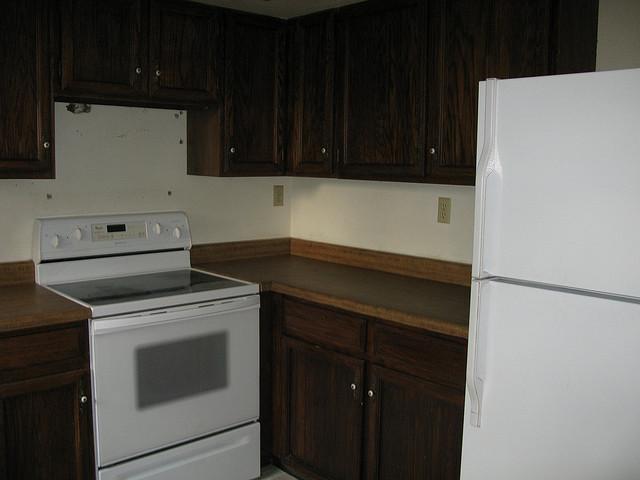What color is the shelf?
Concise answer only. Brown. How many candles are in this scene?
Quick response, please. 0. What is hanging on the freezer door?
Give a very brief answer. Nothing. Does the stove run on electric or gas?
Write a very short answer. Electric. Is there a dishwasher in this photo?
Concise answer only. No. Is there anything on the wall under the cabinet?
Write a very short answer. Yes. Is it a gas or electric stove?
Short answer required. Electric. Are the appliances stainless?
Quick response, please. No. Is there anything on the counter?
Give a very brief answer. No. What is the main color in the room?
Quick response, please. Brown. Is there a microwave in this photo?
Answer briefly. No. How is the stovetop powered?
Quick response, please. Electricity. What color is the stove?
Keep it brief. White. What style kitchen is it?
Keep it brief. Modern. How many appliances in this photo?
Short answer required. 2. How many rings are on the stove?
Keep it brief. 4. Does this place look lived in?
Give a very brief answer. No. What color are the cabinets?
Be succinct. Brown. Is the stove gas or electric?
Short answer required. Electric. What room is this?
Quick response, please. Kitchen. What color are the appliances?
Give a very brief answer. White. Where is the phone?
Concise answer only. Nowhere. Is this a modern microwave?
Write a very short answer. No. Are the lights on?
Write a very short answer. No. What is one advantage of the oven placement?
Give a very brief answer. Counter space. Is that a hood vent over the cooktop?
Quick response, please. No. What is on the refrigerator?
Short answer required. Nothing. What type of energy source does the stove use?
Be succinct. Electric. How many different types of door are visible?
Be succinct. 4. What color is dominant?
Give a very brief answer. Brown. What is the refrigerator made of?
Quick response, please. Metal. Are there any arched doorways?
Keep it brief. No. 